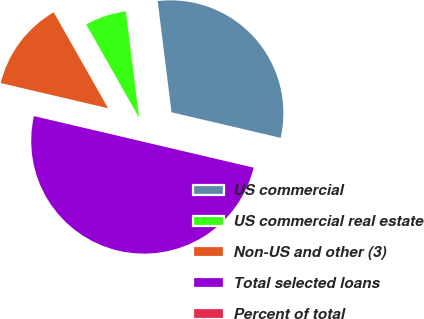Convert chart. <chart><loc_0><loc_0><loc_500><loc_500><pie_chart><fcel>US commercial<fcel>US commercial real estate<fcel>Non-US and other (3)<fcel>Total selected loans<fcel>Percent of total<nl><fcel>30.63%<fcel>6.24%<fcel>13.12%<fcel>49.99%<fcel>0.01%<nl></chart> 